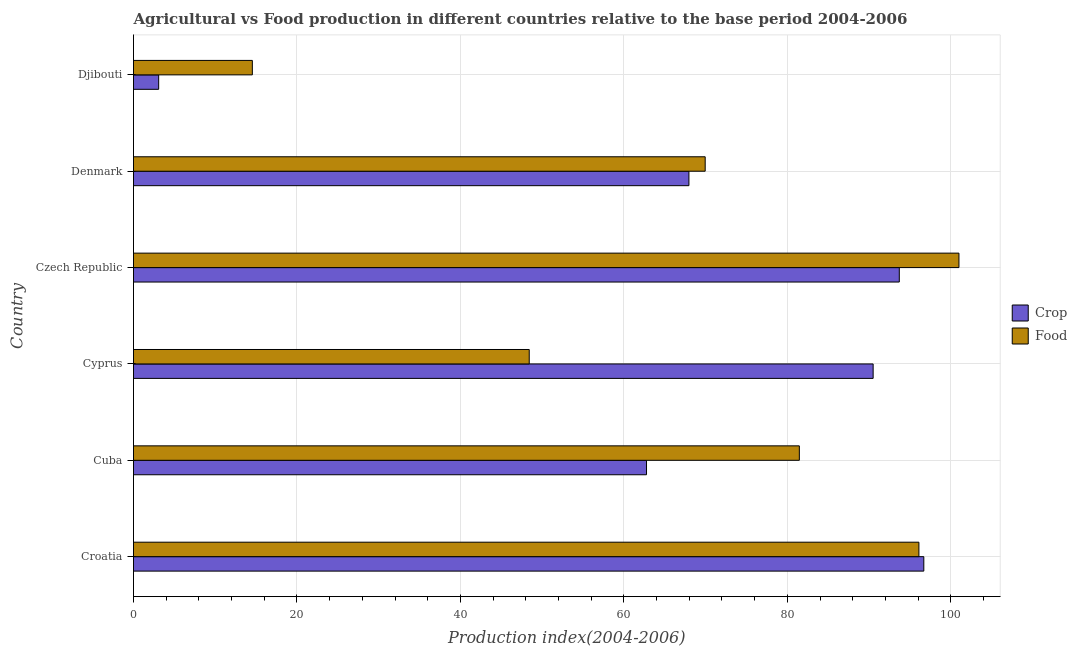How many different coloured bars are there?
Your response must be concise. 2. How many groups of bars are there?
Your answer should be compact. 6. Are the number of bars per tick equal to the number of legend labels?
Provide a short and direct response. Yes. Are the number of bars on each tick of the Y-axis equal?
Your answer should be compact. Yes. How many bars are there on the 3rd tick from the bottom?
Your response must be concise. 2. What is the label of the 1st group of bars from the top?
Give a very brief answer. Djibouti. What is the food production index in Czech Republic?
Ensure brevity in your answer.  101. Across all countries, what is the maximum crop production index?
Offer a very short reply. 96.7. Across all countries, what is the minimum food production index?
Provide a succinct answer. 14.54. In which country was the crop production index maximum?
Give a very brief answer. Croatia. In which country was the food production index minimum?
Keep it short and to the point. Djibouti. What is the total food production index in the graph?
Ensure brevity in your answer.  411.48. What is the difference between the food production index in Cuba and that in Djibouti?
Offer a terse response. 66.93. What is the difference between the food production index in Czech Republic and the crop production index in Cyprus?
Your response must be concise. 10.5. What is the average crop production index per country?
Ensure brevity in your answer.  69.12. In how many countries, is the crop production index greater than 88 ?
Your answer should be very brief. 3. What is the ratio of the crop production index in Cuba to that in Czech Republic?
Ensure brevity in your answer.  0.67. What is the difference between the highest and the lowest food production index?
Give a very brief answer. 86.46. In how many countries, is the crop production index greater than the average crop production index taken over all countries?
Offer a terse response. 3. What does the 2nd bar from the top in Djibouti represents?
Provide a short and direct response. Crop. What does the 2nd bar from the bottom in Djibouti represents?
Your response must be concise. Food. How many countries are there in the graph?
Offer a very short reply. 6. Are the values on the major ticks of X-axis written in scientific E-notation?
Your answer should be very brief. No. Does the graph contain any zero values?
Your answer should be very brief. No. Where does the legend appear in the graph?
Your answer should be compact. Center right. What is the title of the graph?
Your answer should be compact. Agricultural vs Food production in different countries relative to the base period 2004-2006. What is the label or title of the X-axis?
Ensure brevity in your answer.  Production index(2004-2006). What is the Production index(2004-2006) in Crop in Croatia?
Ensure brevity in your answer.  96.7. What is the Production index(2004-2006) in Food in Croatia?
Give a very brief answer. 96.1. What is the Production index(2004-2006) of Crop in Cuba?
Make the answer very short. 62.77. What is the Production index(2004-2006) in Food in Cuba?
Offer a terse response. 81.47. What is the Production index(2004-2006) of Crop in Cyprus?
Offer a very short reply. 90.5. What is the Production index(2004-2006) of Food in Cyprus?
Give a very brief answer. 48.42. What is the Production index(2004-2006) in Crop in Czech Republic?
Your answer should be very brief. 93.7. What is the Production index(2004-2006) in Food in Czech Republic?
Make the answer very short. 101. What is the Production index(2004-2006) in Crop in Denmark?
Provide a succinct answer. 67.96. What is the Production index(2004-2006) in Food in Denmark?
Your response must be concise. 69.95. What is the Production index(2004-2006) in Crop in Djibouti?
Your answer should be compact. 3.08. What is the Production index(2004-2006) of Food in Djibouti?
Give a very brief answer. 14.54. Across all countries, what is the maximum Production index(2004-2006) of Crop?
Offer a very short reply. 96.7. Across all countries, what is the maximum Production index(2004-2006) in Food?
Give a very brief answer. 101. Across all countries, what is the minimum Production index(2004-2006) of Crop?
Offer a terse response. 3.08. Across all countries, what is the minimum Production index(2004-2006) of Food?
Your answer should be compact. 14.54. What is the total Production index(2004-2006) in Crop in the graph?
Your answer should be very brief. 414.71. What is the total Production index(2004-2006) of Food in the graph?
Your response must be concise. 411.48. What is the difference between the Production index(2004-2006) in Crop in Croatia and that in Cuba?
Make the answer very short. 33.93. What is the difference between the Production index(2004-2006) in Food in Croatia and that in Cuba?
Provide a succinct answer. 14.63. What is the difference between the Production index(2004-2006) of Food in Croatia and that in Cyprus?
Keep it short and to the point. 47.68. What is the difference between the Production index(2004-2006) of Crop in Croatia and that in Denmark?
Keep it short and to the point. 28.74. What is the difference between the Production index(2004-2006) of Food in Croatia and that in Denmark?
Provide a succinct answer. 26.15. What is the difference between the Production index(2004-2006) in Crop in Croatia and that in Djibouti?
Offer a very short reply. 93.62. What is the difference between the Production index(2004-2006) in Food in Croatia and that in Djibouti?
Offer a very short reply. 81.56. What is the difference between the Production index(2004-2006) of Crop in Cuba and that in Cyprus?
Ensure brevity in your answer.  -27.73. What is the difference between the Production index(2004-2006) of Food in Cuba and that in Cyprus?
Offer a very short reply. 33.05. What is the difference between the Production index(2004-2006) of Crop in Cuba and that in Czech Republic?
Offer a very short reply. -30.93. What is the difference between the Production index(2004-2006) in Food in Cuba and that in Czech Republic?
Provide a short and direct response. -19.53. What is the difference between the Production index(2004-2006) of Crop in Cuba and that in Denmark?
Make the answer very short. -5.19. What is the difference between the Production index(2004-2006) in Food in Cuba and that in Denmark?
Ensure brevity in your answer.  11.52. What is the difference between the Production index(2004-2006) of Crop in Cuba and that in Djibouti?
Keep it short and to the point. 59.69. What is the difference between the Production index(2004-2006) of Food in Cuba and that in Djibouti?
Your answer should be very brief. 66.93. What is the difference between the Production index(2004-2006) of Food in Cyprus and that in Czech Republic?
Ensure brevity in your answer.  -52.58. What is the difference between the Production index(2004-2006) in Crop in Cyprus and that in Denmark?
Your answer should be very brief. 22.54. What is the difference between the Production index(2004-2006) of Food in Cyprus and that in Denmark?
Provide a short and direct response. -21.53. What is the difference between the Production index(2004-2006) in Crop in Cyprus and that in Djibouti?
Your answer should be compact. 87.42. What is the difference between the Production index(2004-2006) in Food in Cyprus and that in Djibouti?
Provide a short and direct response. 33.88. What is the difference between the Production index(2004-2006) in Crop in Czech Republic and that in Denmark?
Make the answer very short. 25.74. What is the difference between the Production index(2004-2006) of Food in Czech Republic and that in Denmark?
Give a very brief answer. 31.05. What is the difference between the Production index(2004-2006) of Crop in Czech Republic and that in Djibouti?
Your answer should be very brief. 90.62. What is the difference between the Production index(2004-2006) in Food in Czech Republic and that in Djibouti?
Your answer should be very brief. 86.46. What is the difference between the Production index(2004-2006) of Crop in Denmark and that in Djibouti?
Offer a terse response. 64.88. What is the difference between the Production index(2004-2006) in Food in Denmark and that in Djibouti?
Give a very brief answer. 55.41. What is the difference between the Production index(2004-2006) in Crop in Croatia and the Production index(2004-2006) in Food in Cuba?
Give a very brief answer. 15.23. What is the difference between the Production index(2004-2006) in Crop in Croatia and the Production index(2004-2006) in Food in Cyprus?
Provide a succinct answer. 48.28. What is the difference between the Production index(2004-2006) of Crop in Croatia and the Production index(2004-2006) of Food in Denmark?
Offer a very short reply. 26.75. What is the difference between the Production index(2004-2006) in Crop in Croatia and the Production index(2004-2006) in Food in Djibouti?
Provide a short and direct response. 82.16. What is the difference between the Production index(2004-2006) in Crop in Cuba and the Production index(2004-2006) in Food in Cyprus?
Offer a very short reply. 14.35. What is the difference between the Production index(2004-2006) of Crop in Cuba and the Production index(2004-2006) of Food in Czech Republic?
Provide a succinct answer. -38.23. What is the difference between the Production index(2004-2006) of Crop in Cuba and the Production index(2004-2006) of Food in Denmark?
Your answer should be compact. -7.18. What is the difference between the Production index(2004-2006) of Crop in Cuba and the Production index(2004-2006) of Food in Djibouti?
Your answer should be very brief. 48.23. What is the difference between the Production index(2004-2006) in Crop in Cyprus and the Production index(2004-2006) in Food in Czech Republic?
Your response must be concise. -10.5. What is the difference between the Production index(2004-2006) in Crop in Cyprus and the Production index(2004-2006) in Food in Denmark?
Provide a short and direct response. 20.55. What is the difference between the Production index(2004-2006) in Crop in Cyprus and the Production index(2004-2006) in Food in Djibouti?
Your answer should be compact. 75.96. What is the difference between the Production index(2004-2006) of Crop in Czech Republic and the Production index(2004-2006) of Food in Denmark?
Make the answer very short. 23.75. What is the difference between the Production index(2004-2006) in Crop in Czech Republic and the Production index(2004-2006) in Food in Djibouti?
Ensure brevity in your answer.  79.16. What is the difference between the Production index(2004-2006) of Crop in Denmark and the Production index(2004-2006) of Food in Djibouti?
Keep it short and to the point. 53.42. What is the average Production index(2004-2006) in Crop per country?
Your answer should be compact. 69.12. What is the average Production index(2004-2006) of Food per country?
Make the answer very short. 68.58. What is the difference between the Production index(2004-2006) of Crop and Production index(2004-2006) of Food in Croatia?
Offer a very short reply. 0.6. What is the difference between the Production index(2004-2006) of Crop and Production index(2004-2006) of Food in Cuba?
Make the answer very short. -18.7. What is the difference between the Production index(2004-2006) in Crop and Production index(2004-2006) in Food in Cyprus?
Your answer should be compact. 42.08. What is the difference between the Production index(2004-2006) in Crop and Production index(2004-2006) in Food in Czech Republic?
Provide a short and direct response. -7.3. What is the difference between the Production index(2004-2006) in Crop and Production index(2004-2006) in Food in Denmark?
Your answer should be compact. -1.99. What is the difference between the Production index(2004-2006) in Crop and Production index(2004-2006) in Food in Djibouti?
Offer a very short reply. -11.46. What is the ratio of the Production index(2004-2006) in Crop in Croatia to that in Cuba?
Your answer should be very brief. 1.54. What is the ratio of the Production index(2004-2006) in Food in Croatia to that in Cuba?
Provide a succinct answer. 1.18. What is the ratio of the Production index(2004-2006) in Crop in Croatia to that in Cyprus?
Ensure brevity in your answer.  1.07. What is the ratio of the Production index(2004-2006) of Food in Croatia to that in Cyprus?
Give a very brief answer. 1.98. What is the ratio of the Production index(2004-2006) of Crop in Croatia to that in Czech Republic?
Provide a succinct answer. 1.03. What is the ratio of the Production index(2004-2006) in Food in Croatia to that in Czech Republic?
Give a very brief answer. 0.95. What is the ratio of the Production index(2004-2006) of Crop in Croatia to that in Denmark?
Offer a terse response. 1.42. What is the ratio of the Production index(2004-2006) in Food in Croatia to that in Denmark?
Offer a terse response. 1.37. What is the ratio of the Production index(2004-2006) of Crop in Croatia to that in Djibouti?
Your response must be concise. 31.4. What is the ratio of the Production index(2004-2006) of Food in Croatia to that in Djibouti?
Make the answer very short. 6.61. What is the ratio of the Production index(2004-2006) in Crop in Cuba to that in Cyprus?
Make the answer very short. 0.69. What is the ratio of the Production index(2004-2006) of Food in Cuba to that in Cyprus?
Ensure brevity in your answer.  1.68. What is the ratio of the Production index(2004-2006) of Crop in Cuba to that in Czech Republic?
Offer a terse response. 0.67. What is the ratio of the Production index(2004-2006) in Food in Cuba to that in Czech Republic?
Your answer should be compact. 0.81. What is the ratio of the Production index(2004-2006) of Crop in Cuba to that in Denmark?
Your response must be concise. 0.92. What is the ratio of the Production index(2004-2006) of Food in Cuba to that in Denmark?
Your response must be concise. 1.16. What is the ratio of the Production index(2004-2006) of Crop in Cuba to that in Djibouti?
Make the answer very short. 20.38. What is the ratio of the Production index(2004-2006) in Food in Cuba to that in Djibouti?
Provide a short and direct response. 5.6. What is the ratio of the Production index(2004-2006) of Crop in Cyprus to that in Czech Republic?
Offer a terse response. 0.97. What is the ratio of the Production index(2004-2006) in Food in Cyprus to that in Czech Republic?
Your answer should be compact. 0.48. What is the ratio of the Production index(2004-2006) in Crop in Cyprus to that in Denmark?
Keep it short and to the point. 1.33. What is the ratio of the Production index(2004-2006) of Food in Cyprus to that in Denmark?
Offer a terse response. 0.69. What is the ratio of the Production index(2004-2006) in Crop in Cyprus to that in Djibouti?
Provide a succinct answer. 29.38. What is the ratio of the Production index(2004-2006) of Food in Cyprus to that in Djibouti?
Your answer should be very brief. 3.33. What is the ratio of the Production index(2004-2006) in Crop in Czech Republic to that in Denmark?
Make the answer very short. 1.38. What is the ratio of the Production index(2004-2006) in Food in Czech Republic to that in Denmark?
Provide a succinct answer. 1.44. What is the ratio of the Production index(2004-2006) in Crop in Czech Republic to that in Djibouti?
Your response must be concise. 30.42. What is the ratio of the Production index(2004-2006) of Food in Czech Republic to that in Djibouti?
Provide a short and direct response. 6.95. What is the ratio of the Production index(2004-2006) in Crop in Denmark to that in Djibouti?
Your answer should be compact. 22.06. What is the ratio of the Production index(2004-2006) of Food in Denmark to that in Djibouti?
Ensure brevity in your answer.  4.81. What is the difference between the highest and the second highest Production index(2004-2006) in Food?
Offer a terse response. 4.9. What is the difference between the highest and the lowest Production index(2004-2006) in Crop?
Your response must be concise. 93.62. What is the difference between the highest and the lowest Production index(2004-2006) of Food?
Offer a terse response. 86.46. 